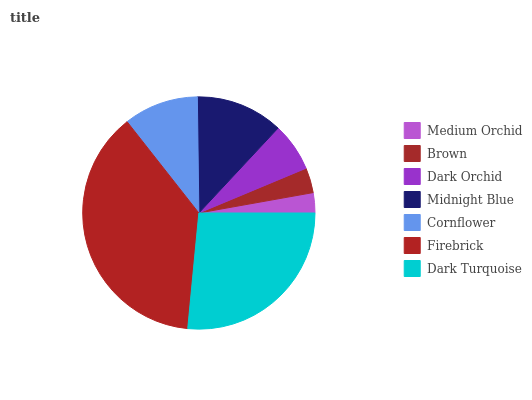Is Medium Orchid the minimum?
Answer yes or no. Yes. Is Firebrick the maximum?
Answer yes or no. Yes. Is Brown the minimum?
Answer yes or no. No. Is Brown the maximum?
Answer yes or no. No. Is Brown greater than Medium Orchid?
Answer yes or no. Yes. Is Medium Orchid less than Brown?
Answer yes or no. Yes. Is Medium Orchid greater than Brown?
Answer yes or no. No. Is Brown less than Medium Orchid?
Answer yes or no. No. Is Cornflower the high median?
Answer yes or no. Yes. Is Cornflower the low median?
Answer yes or no. Yes. Is Brown the high median?
Answer yes or no. No. Is Midnight Blue the low median?
Answer yes or no. No. 